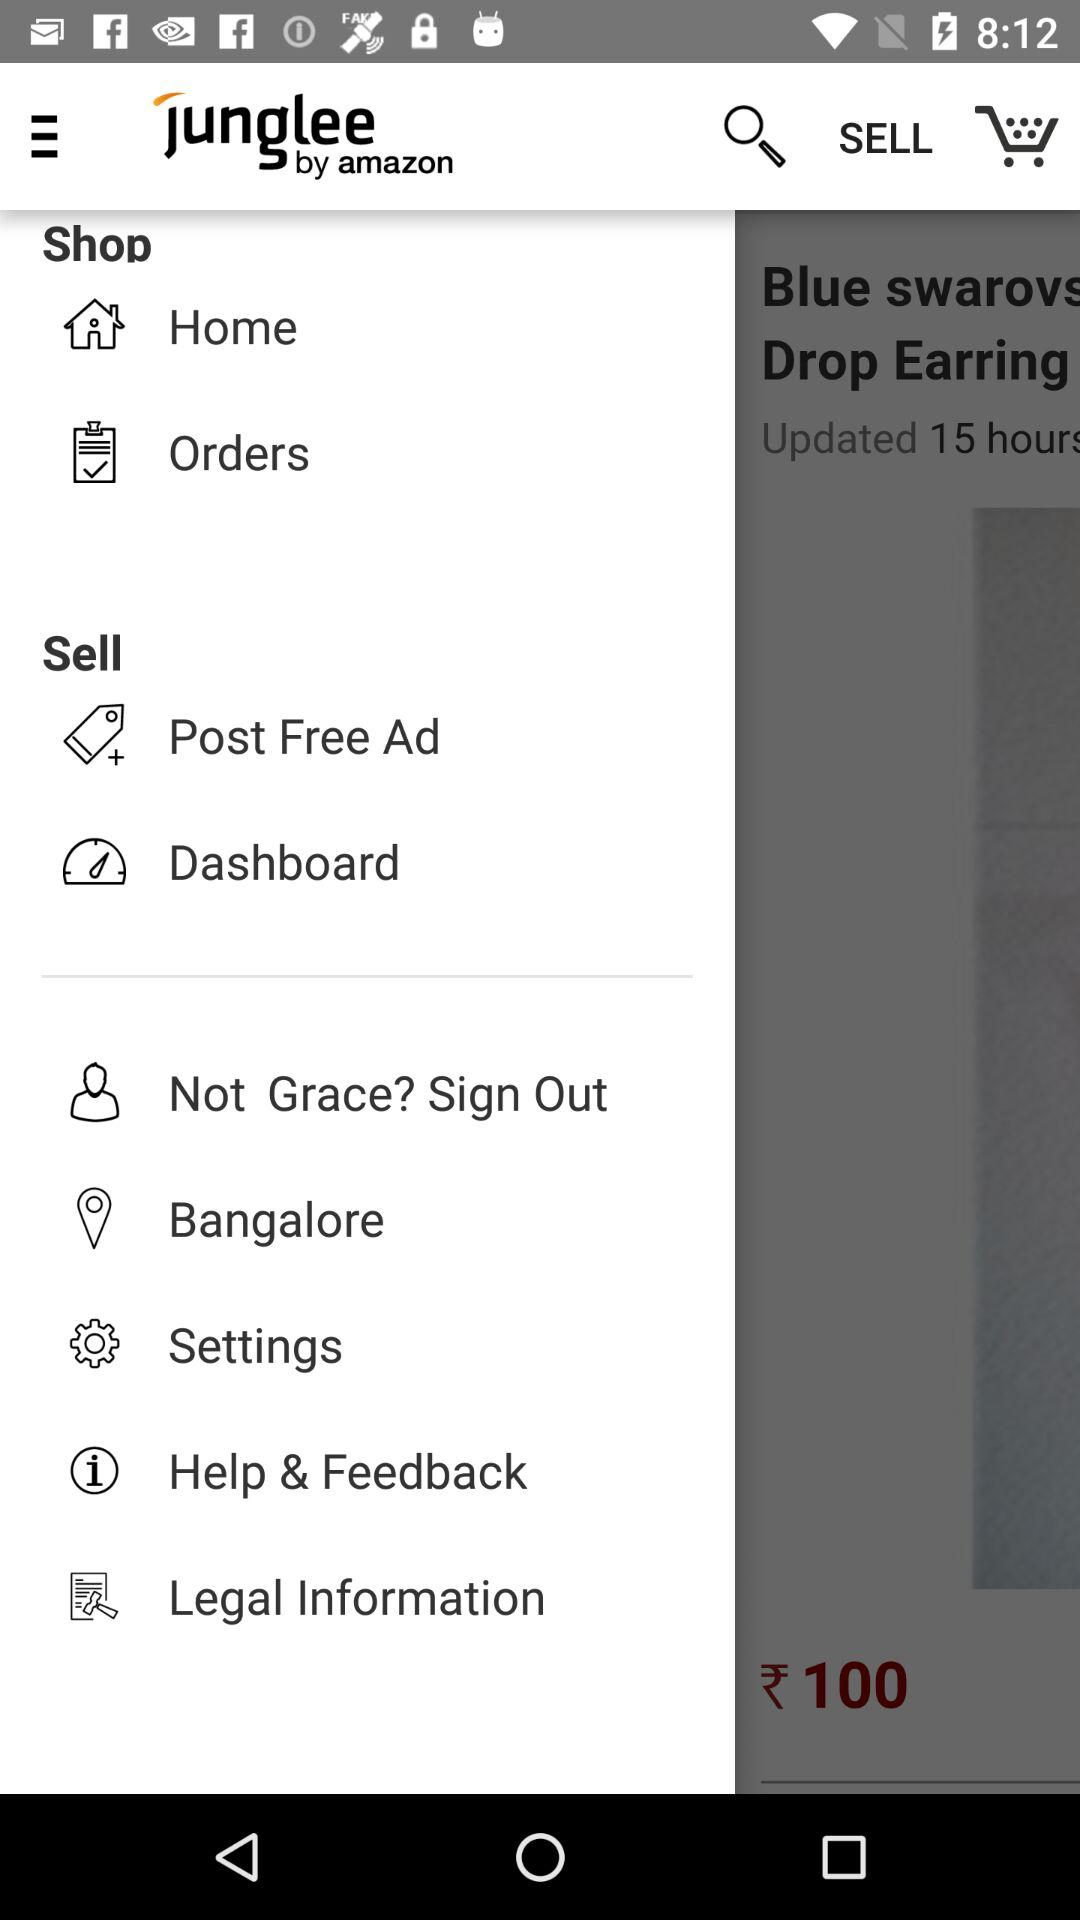What is the application name? The application name is "junglee". 